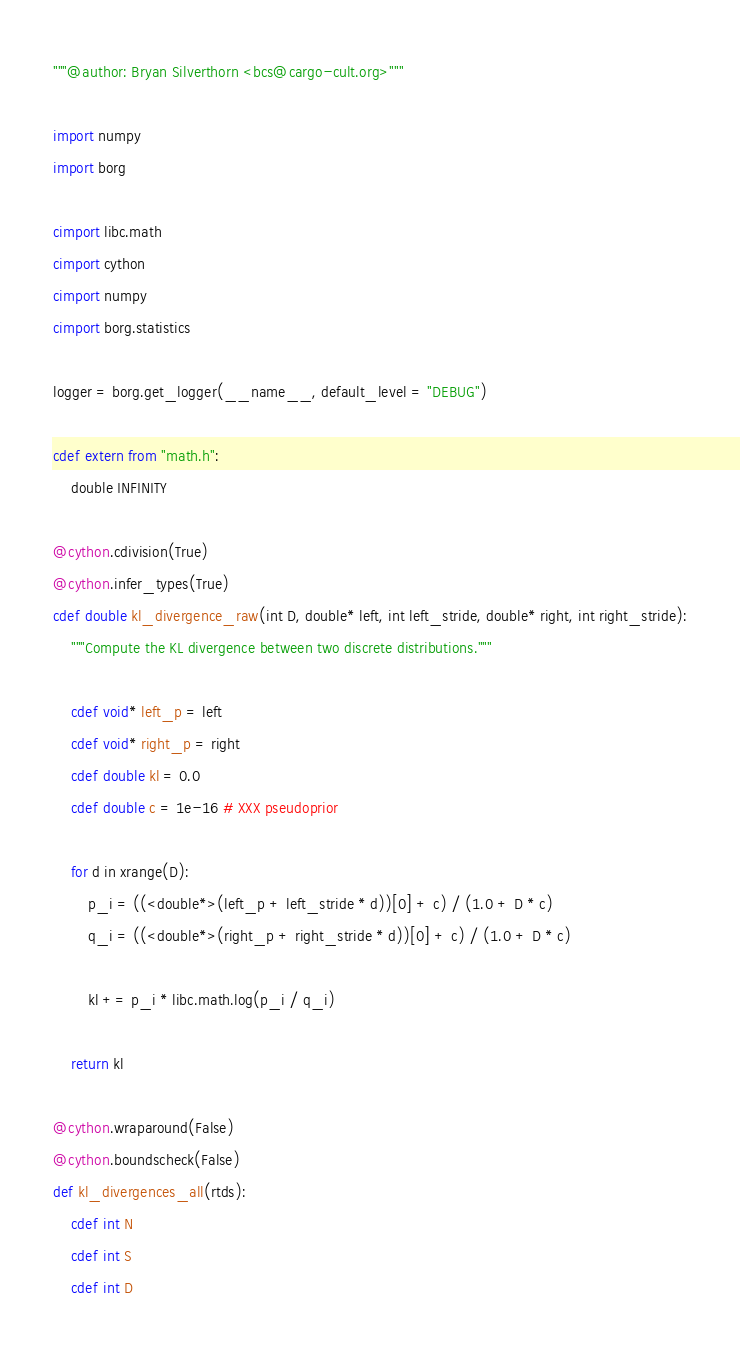Convert code to text. <code><loc_0><loc_0><loc_500><loc_500><_Cython_>"""@author: Bryan Silverthorn <bcs@cargo-cult.org>"""

import numpy
import borg

cimport libc.math
cimport cython
cimport numpy
cimport borg.statistics

logger = borg.get_logger(__name__, default_level = "DEBUG")

cdef extern from "math.h":
    double INFINITY

@cython.cdivision(True)
@cython.infer_types(True)
cdef double kl_divergence_raw(int D, double* left, int left_stride, double* right, int right_stride):
    """Compute the KL divergence between two discrete distributions."""

    cdef void* left_p = left
    cdef void* right_p = right
    cdef double kl = 0.0
    cdef double c = 1e-16 # XXX pseudoprior

    for d in xrange(D):
        p_i = ((<double*>(left_p + left_stride * d))[0] + c) / (1.0 + D * c)
        q_i = ((<double*>(right_p + right_stride * d))[0] + c) / (1.0 + D * c)

        kl += p_i * libc.math.log(p_i / q_i)

    return kl

@cython.wraparound(False)
@cython.boundscheck(False)
def kl_divergences_all(rtds):
    cdef int N
    cdef int S
    cdef int D
</code> 